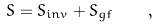Convert formula to latex. <formula><loc_0><loc_0><loc_500><loc_500>S = S _ { i n v } + S _ { g f } \quad ,</formula> 